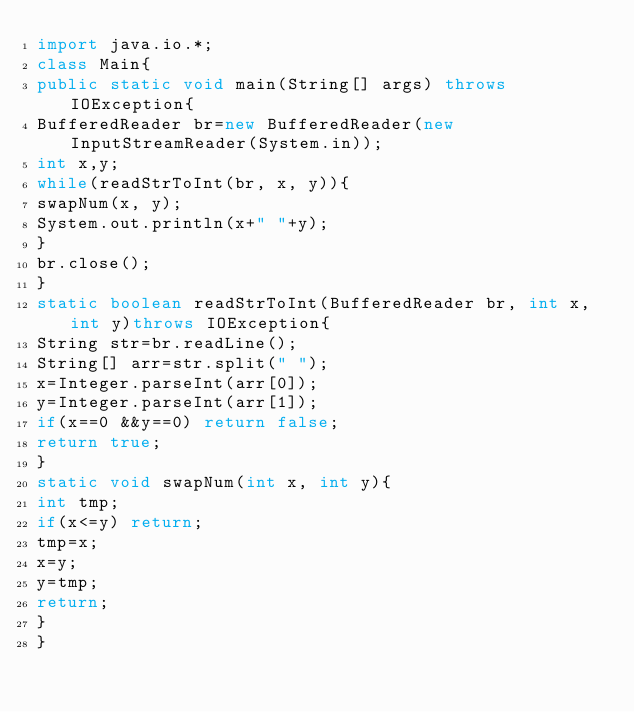<code> <loc_0><loc_0><loc_500><loc_500><_Java_>import java.io.*;
class Main{
public static void main(String[] args) throws IOException{
BufferedReader br=new BufferedReader(new InputStreamReader(System.in));
int x,y;
while(readStrToInt(br, x, y)){
swapNum(x, y);
System.out.println(x+" "+y);
}
br.close();
}
static boolean readStrToInt(BufferedReader br, int x, int y)throws IOException{
String str=br.readLine();
String[] arr=str.split(" ");
x=Integer.parseInt(arr[0]);
y=Integer.parseInt(arr[1]);
if(x==0 &&y==0) return false;
return true;
}
static void swapNum(int x, int y){
int tmp;
if(x<=y) return;
tmp=x;
x=y;
y=tmp;
return;
}
}</code> 